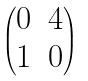Convert formula to latex. <formula><loc_0><loc_0><loc_500><loc_500>\begin{pmatrix} 0 & 4 \\ 1 & 0 \end{pmatrix}</formula> 